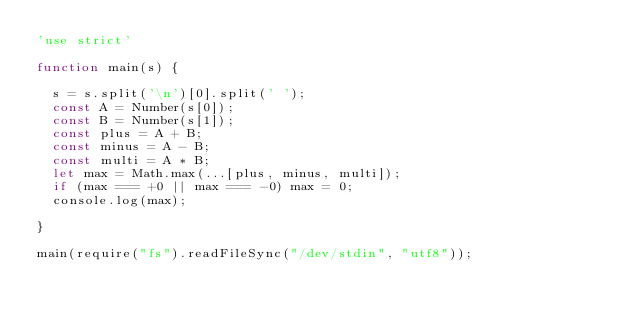<code> <loc_0><loc_0><loc_500><loc_500><_JavaScript_>'use strict'

function main(s) {

  s = s.split('\n')[0].split(' ');
  const A = Number(s[0]);
  const B = Number(s[1]);
  const plus = A + B;
  const minus = A - B;
  const multi = A * B;
  let max = Math.max(...[plus, minus, multi]);
  if (max === +0 || max === -0) max = 0;
  console.log(max);

}

main(require("fs").readFileSync("/dev/stdin", "utf8"));
</code> 